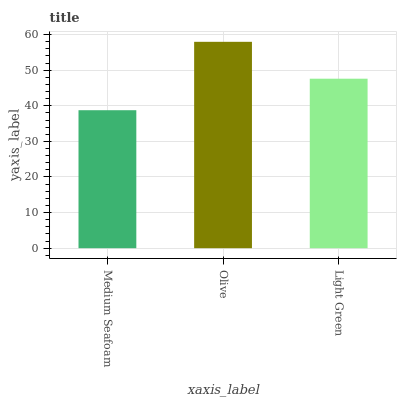Is Medium Seafoam the minimum?
Answer yes or no. Yes. Is Olive the maximum?
Answer yes or no. Yes. Is Light Green the minimum?
Answer yes or no. No. Is Light Green the maximum?
Answer yes or no. No. Is Olive greater than Light Green?
Answer yes or no. Yes. Is Light Green less than Olive?
Answer yes or no. Yes. Is Light Green greater than Olive?
Answer yes or no. No. Is Olive less than Light Green?
Answer yes or no. No. Is Light Green the high median?
Answer yes or no. Yes. Is Light Green the low median?
Answer yes or no. Yes. Is Olive the high median?
Answer yes or no. No. Is Olive the low median?
Answer yes or no. No. 